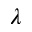<formula> <loc_0><loc_0><loc_500><loc_500>\lambda</formula> 